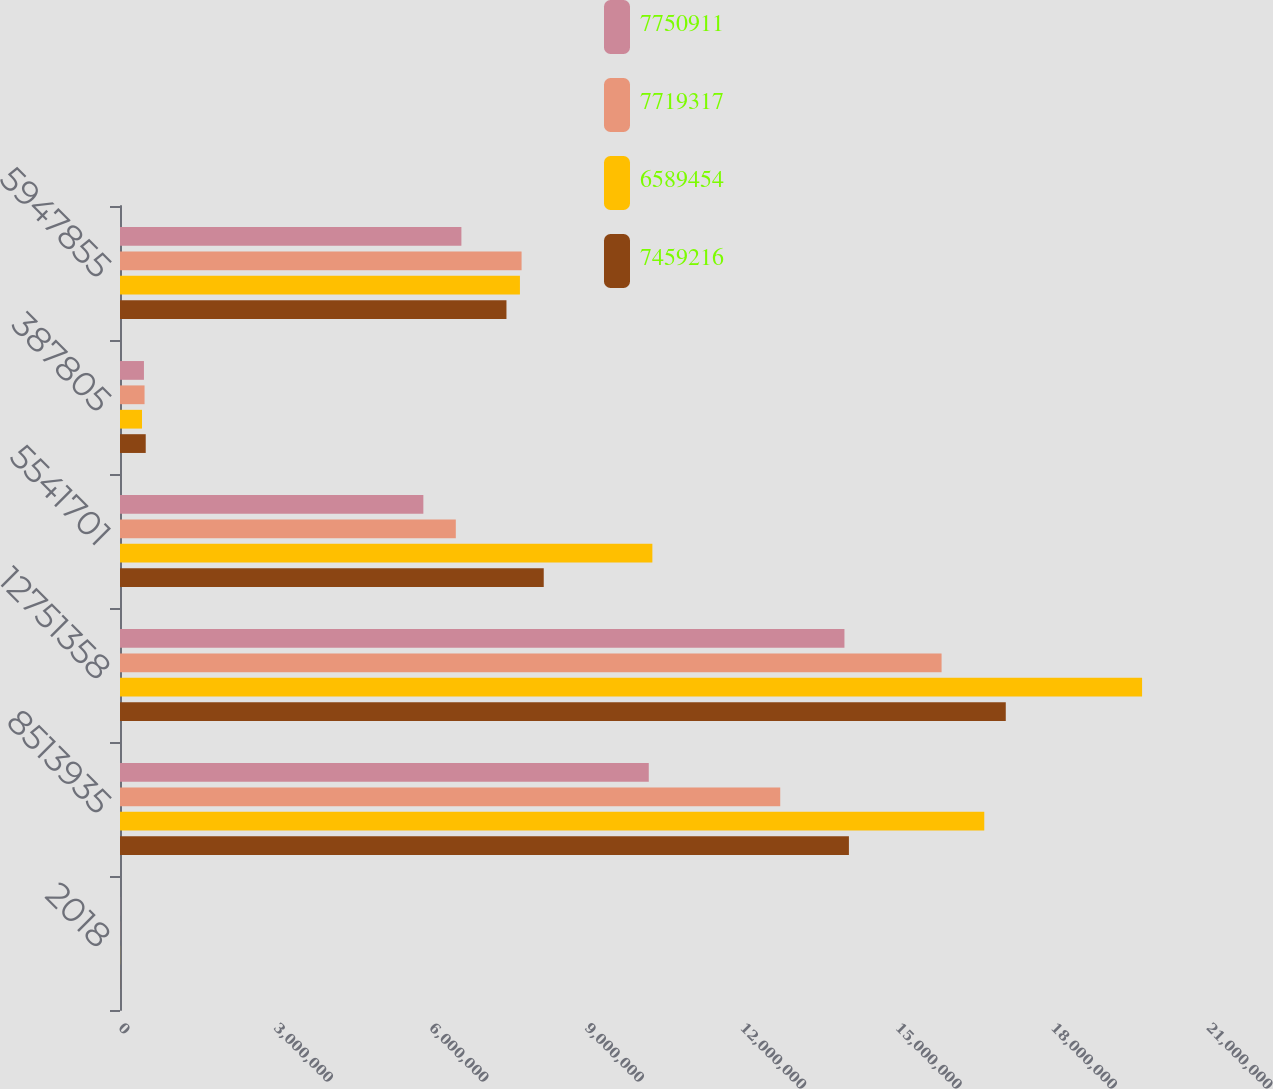Convert chart to OTSL. <chart><loc_0><loc_0><loc_500><loc_500><stacked_bar_chart><ecel><fcel>2018<fcel>8513935<fcel>12751358<fcel>5541701<fcel>387805<fcel>5947855<nl><fcel>7.75091e+06<fcel>2017<fcel>1.02061e+07<fcel>1.39829e+07<fcel>5.85513e+06<fcel>461954<fcel>6.58945e+06<nl><fcel>7.71932e+06<fcel>2016<fcel>1.27433e+07<fcel>1.58578e+07<fcel>6.48167e+06<fcel>473882<fcel>7.75091e+06<nl><fcel>6.58945e+06<fcel>2015<fcel>1.66816e+07<fcel>1.97276e+07<fcel>1.02755e+07<fcel>424206<fcel>7.71932e+06<nl><fcel>7.45922e+06<fcel>2014<fcel>1.40691e+07<fcel>1.70966e+07<fcel>8.17879e+06<fcel>496524<fcel>7.45922e+06<nl></chart> 